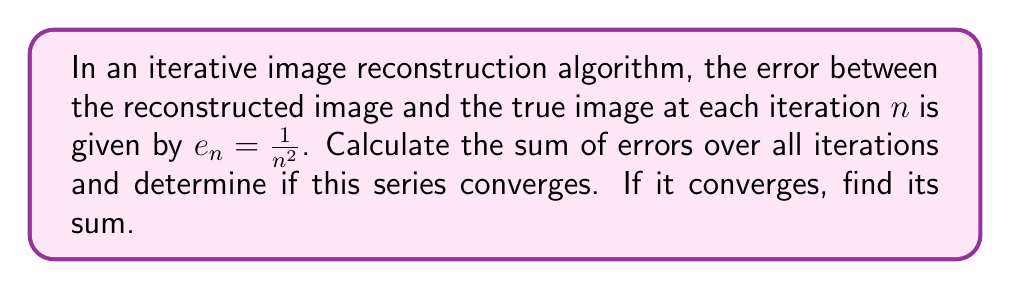What is the answer to this math problem? To solve this problem, we need to follow these steps:

1) First, we identify the series:
   $$\sum_{n=1}^{\infty} \frac{1}{n^2}$$

2) This is a p-series with $p = 2$. We know that p-series converge for $p > 1$.

3) Since $2 > 1$, this series converges.

4) The sum of this series is known as the Basel problem, and its value is:
   $$\sum_{n=1}^{\infty} \frac{1}{n^2} = \frac{\pi^2}{6}$$

5) This result was proven by Euler in 1735 and has significant implications in various fields of mathematics and physics.

6) In the context of image reconstruction, this means that the total error over all iterations is finite and equal to $\frac{\pi^2}{6}$.

7) The convergence of this series implies that the iterative algorithm will eventually produce a result that is arbitrarily close to the true image, given enough iterations.
Answer: The series converges; sum = $\frac{\pi^2}{6}$ 